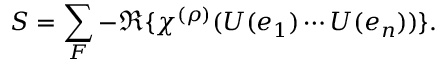Convert formula to latex. <formula><loc_0><loc_0><loc_500><loc_500>S = \sum _ { F } - \Re \{ \chi ^ { ( \rho ) } ( U ( e _ { 1 } ) \cdots U ( e _ { n } ) ) \} .</formula> 